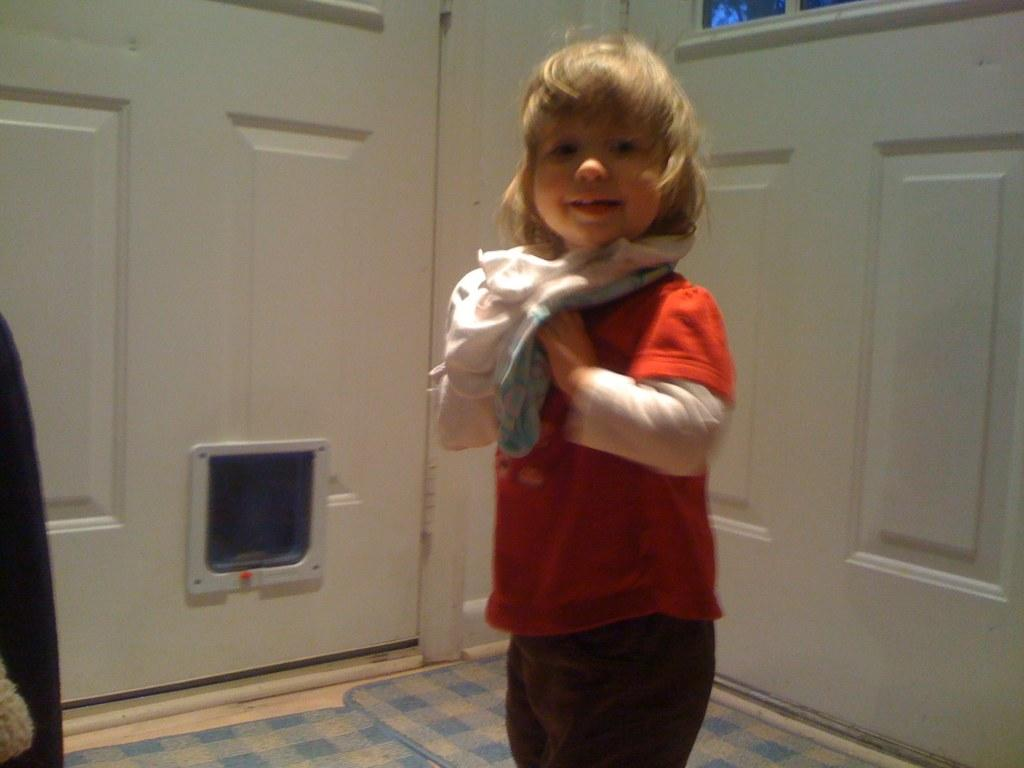What is the main subject of the image? The main subject of the image is a kid. Where is the kid located in the image? The kid is standing on the floor. What type of zephyr can be seen interacting with the kid in the image? There is no zephyr present in the image; it is a kid standing on the floor. What is the kid's mind thinking about in the image? The image does not provide information about the kid's thoughts or mental state. 